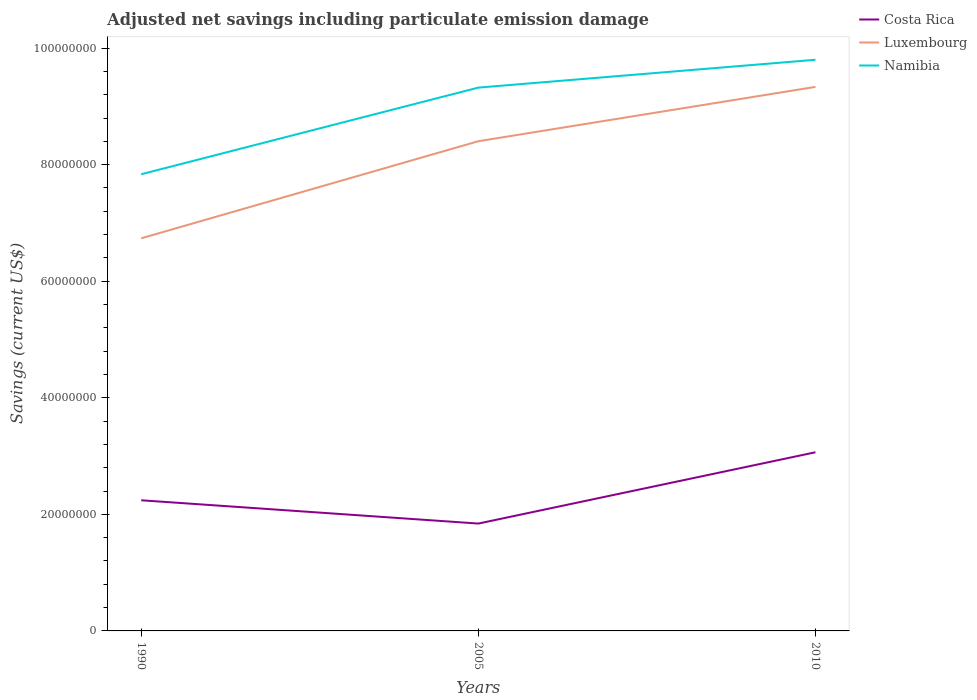Across all years, what is the maximum net savings in Luxembourg?
Your response must be concise. 6.74e+07. In which year was the net savings in Namibia maximum?
Your answer should be very brief. 1990. What is the total net savings in Costa Rica in the graph?
Provide a short and direct response. -1.22e+07. What is the difference between the highest and the second highest net savings in Costa Rica?
Provide a succinct answer. 1.22e+07. How many years are there in the graph?
Your answer should be very brief. 3. What is the difference between two consecutive major ticks on the Y-axis?
Offer a very short reply. 2.00e+07. Where does the legend appear in the graph?
Make the answer very short. Top right. What is the title of the graph?
Keep it short and to the point. Adjusted net savings including particulate emission damage. Does "Bahrain" appear as one of the legend labels in the graph?
Your answer should be very brief. No. What is the label or title of the Y-axis?
Provide a succinct answer. Savings (current US$). What is the Savings (current US$) of Costa Rica in 1990?
Provide a succinct answer. 2.24e+07. What is the Savings (current US$) in Luxembourg in 1990?
Make the answer very short. 6.74e+07. What is the Savings (current US$) of Namibia in 1990?
Give a very brief answer. 7.84e+07. What is the Savings (current US$) of Costa Rica in 2005?
Give a very brief answer. 1.84e+07. What is the Savings (current US$) in Luxembourg in 2005?
Your response must be concise. 8.40e+07. What is the Savings (current US$) of Namibia in 2005?
Keep it short and to the point. 9.32e+07. What is the Savings (current US$) in Costa Rica in 2010?
Your response must be concise. 3.07e+07. What is the Savings (current US$) of Luxembourg in 2010?
Provide a short and direct response. 9.33e+07. What is the Savings (current US$) in Namibia in 2010?
Your answer should be compact. 9.80e+07. Across all years, what is the maximum Savings (current US$) in Costa Rica?
Keep it short and to the point. 3.07e+07. Across all years, what is the maximum Savings (current US$) of Luxembourg?
Give a very brief answer. 9.33e+07. Across all years, what is the maximum Savings (current US$) in Namibia?
Your response must be concise. 9.80e+07. Across all years, what is the minimum Savings (current US$) in Costa Rica?
Provide a short and direct response. 1.84e+07. Across all years, what is the minimum Savings (current US$) in Luxembourg?
Your answer should be compact. 6.74e+07. Across all years, what is the minimum Savings (current US$) of Namibia?
Give a very brief answer. 7.84e+07. What is the total Savings (current US$) of Costa Rica in the graph?
Ensure brevity in your answer.  7.15e+07. What is the total Savings (current US$) of Luxembourg in the graph?
Your answer should be compact. 2.45e+08. What is the total Savings (current US$) of Namibia in the graph?
Your answer should be compact. 2.70e+08. What is the difference between the Savings (current US$) in Costa Rica in 1990 and that in 2005?
Provide a succinct answer. 3.99e+06. What is the difference between the Savings (current US$) of Luxembourg in 1990 and that in 2005?
Provide a short and direct response. -1.67e+07. What is the difference between the Savings (current US$) in Namibia in 1990 and that in 2005?
Provide a succinct answer. -1.49e+07. What is the difference between the Savings (current US$) in Costa Rica in 1990 and that in 2010?
Offer a very short reply. -8.24e+06. What is the difference between the Savings (current US$) in Luxembourg in 1990 and that in 2010?
Keep it short and to the point. -2.60e+07. What is the difference between the Savings (current US$) of Namibia in 1990 and that in 2010?
Provide a short and direct response. -1.96e+07. What is the difference between the Savings (current US$) of Costa Rica in 2005 and that in 2010?
Ensure brevity in your answer.  -1.22e+07. What is the difference between the Savings (current US$) of Luxembourg in 2005 and that in 2010?
Provide a succinct answer. -9.32e+06. What is the difference between the Savings (current US$) of Namibia in 2005 and that in 2010?
Your answer should be very brief. -4.78e+06. What is the difference between the Savings (current US$) in Costa Rica in 1990 and the Savings (current US$) in Luxembourg in 2005?
Keep it short and to the point. -6.16e+07. What is the difference between the Savings (current US$) of Costa Rica in 1990 and the Savings (current US$) of Namibia in 2005?
Your response must be concise. -7.08e+07. What is the difference between the Savings (current US$) of Luxembourg in 1990 and the Savings (current US$) of Namibia in 2005?
Offer a terse response. -2.59e+07. What is the difference between the Savings (current US$) in Costa Rica in 1990 and the Savings (current US$) in Luxembourg in 2010?
Keep it short and to the point. -7.09e+07. What is the difference between the Savings (current US$) of Costa Rica in 1990 and the Savings (current US$) of Namibia in 2010?
Provide a short and direct response. -7.56e+07. What is the difference between the Savings (current US$) in Luxembourg in 1990 and the Savings (current US$) in Namibia in 2010?
Provide a succinct answer. -3.06e+07. What is the difference between the Savings (current US$) in Costa Rica in 2005 and the Savings (current US$) in Luxembourg in 2010?
Your answer should be compact. -7.49e+07. What is the difference between the Savings (current US$) in Costa Rica in 2005 and the Savings (current US$) in Namibia in 2010?
Provide a short and direct response. -7.96e+07. What is the difference between the Savings (current US$) in Luxembourg in 2005 and the Savings (current US$) in Namibia in 2010?
Make the answer very short. -1.40e+07. What is the average Savings (current US$) in Costa Rica per year?
Your answer should be compact. 2.38e+07. What is the average Savings (current US$) in Luxembourg per year?
Offer a very short reply. 8.16e+07. What is the average Savings (current US$) in Namibia per year?
Keep it short and to the point. 8.99e+07. In the year 1990, what is the difference between the Savings (current US$) of Costa Rica and Savings (current US$) of Luxembourg?
Offer a very short reply. -4.49e+07. In the year 1990, what is the difference between the Savings (current US$) of Costa Rica and Savings (current US$) of Namibia?
Offer a very short reply. -5.59e+07. In the year 1990, what is the difference between the Savings (current US$) of Luxembourg and Savings (current US$) of Namibia?
Your answer should be very brief. -1.10e+07. In the year 2005, what is the difference between the Savings (current US$) of Costa Rica and Savings (current US$) of Luxembourg?
Your answer should be very brief. -6.56e+07. In the year 2005, what is the difference between the Savings (current US$) of Costa Rica and Savings (current US$) of Namibia?
Provide a short and direct response. -7.48e+07. In the year 2005, what is the difference between the Savings (current US$) in Luxembourg and Savings (current US$) in Namibia?
Ensure brevity in your answer.  -9.20e+06. In the year 2010, what is the difference between the Savings (current US$) in Costa Rica and Savings (current US$) in Luxembourg?
Provide a succinct answer. -6.27e+07. In the year 2010, what is the difference between the Savings (current US$) of Costa Rica and Savings (current US$) of Namibia?
Keep it short and to the point. -6.73e+07. In the year 2010, what is the difference between the Savings (current US$) of Luxembourg and Savings (current US$) of Namibia?
Keep it short and to the point. -4.65e+06. What is the ratio of the Savings (current US$) of Costa Rica in 1990 to that in 2005?
Your response must be concise. 1.22. What is the ratio of the Savings (current US$) in Luxembourg in 1990 to that in 2005?
Ensure brevity in your answer.  0.8. What is the ratio of the Savings (current US$) in Namibia in 1990 to that in 2005?
Keep it short and to the point. 0.84. What is the ratio of the Savings (current US$) of Costa Rica in 1990 to that in 2010?
Offer a terse response. 0.73. What is the ratio of the Savings (current US$) of Luxembourg in 1990 to that in 2010?
Your response must be concise. 0.72. What is the ratio of the Savings (current US$) in Namibia in 1990 to that in 2010?
Ensure brevity in your answer.  0.8. What is the ratio of the Savings (current US$) in Costa Rica in 2005 to that in 2010?
Your response must be concise. 0.6. What is the ratio of the Savings (current US$) of Luxembourg in 2005 to that in 2010?
Keep it short and to the point. 0.9. What is the ratio of the Savings (current US$) in Namibia in 2005 to that in 2010?
Your answer should be very brief. 0.95. What is the difference between the highest and the second highest Savings (current US$) of Costa Rica?
Make the answer very short. 8.24e+06. What is the difference between the highest and the second highest Savings (current US$) in Luxembourg?
Your response must be concise. 9.32e+06. What is the difference between the highest and the second highest Savings (current US$) in Namibia?
Provide a short and direct response. 4.78e+06. What is the difference between the highest and the lowest Savings (current US$) of Costa Rica?
Provide a short and direct response. 1.22e+07. What is the difference between the highest and the lowest Savings (current US$) in Luxembourg?
Keep it short and to the point. 2.60e+07. What is the difference between the highest and the lowest Savings (current US$) in Namibia?
Ensure brevity in your answer.  1.96e+07. 